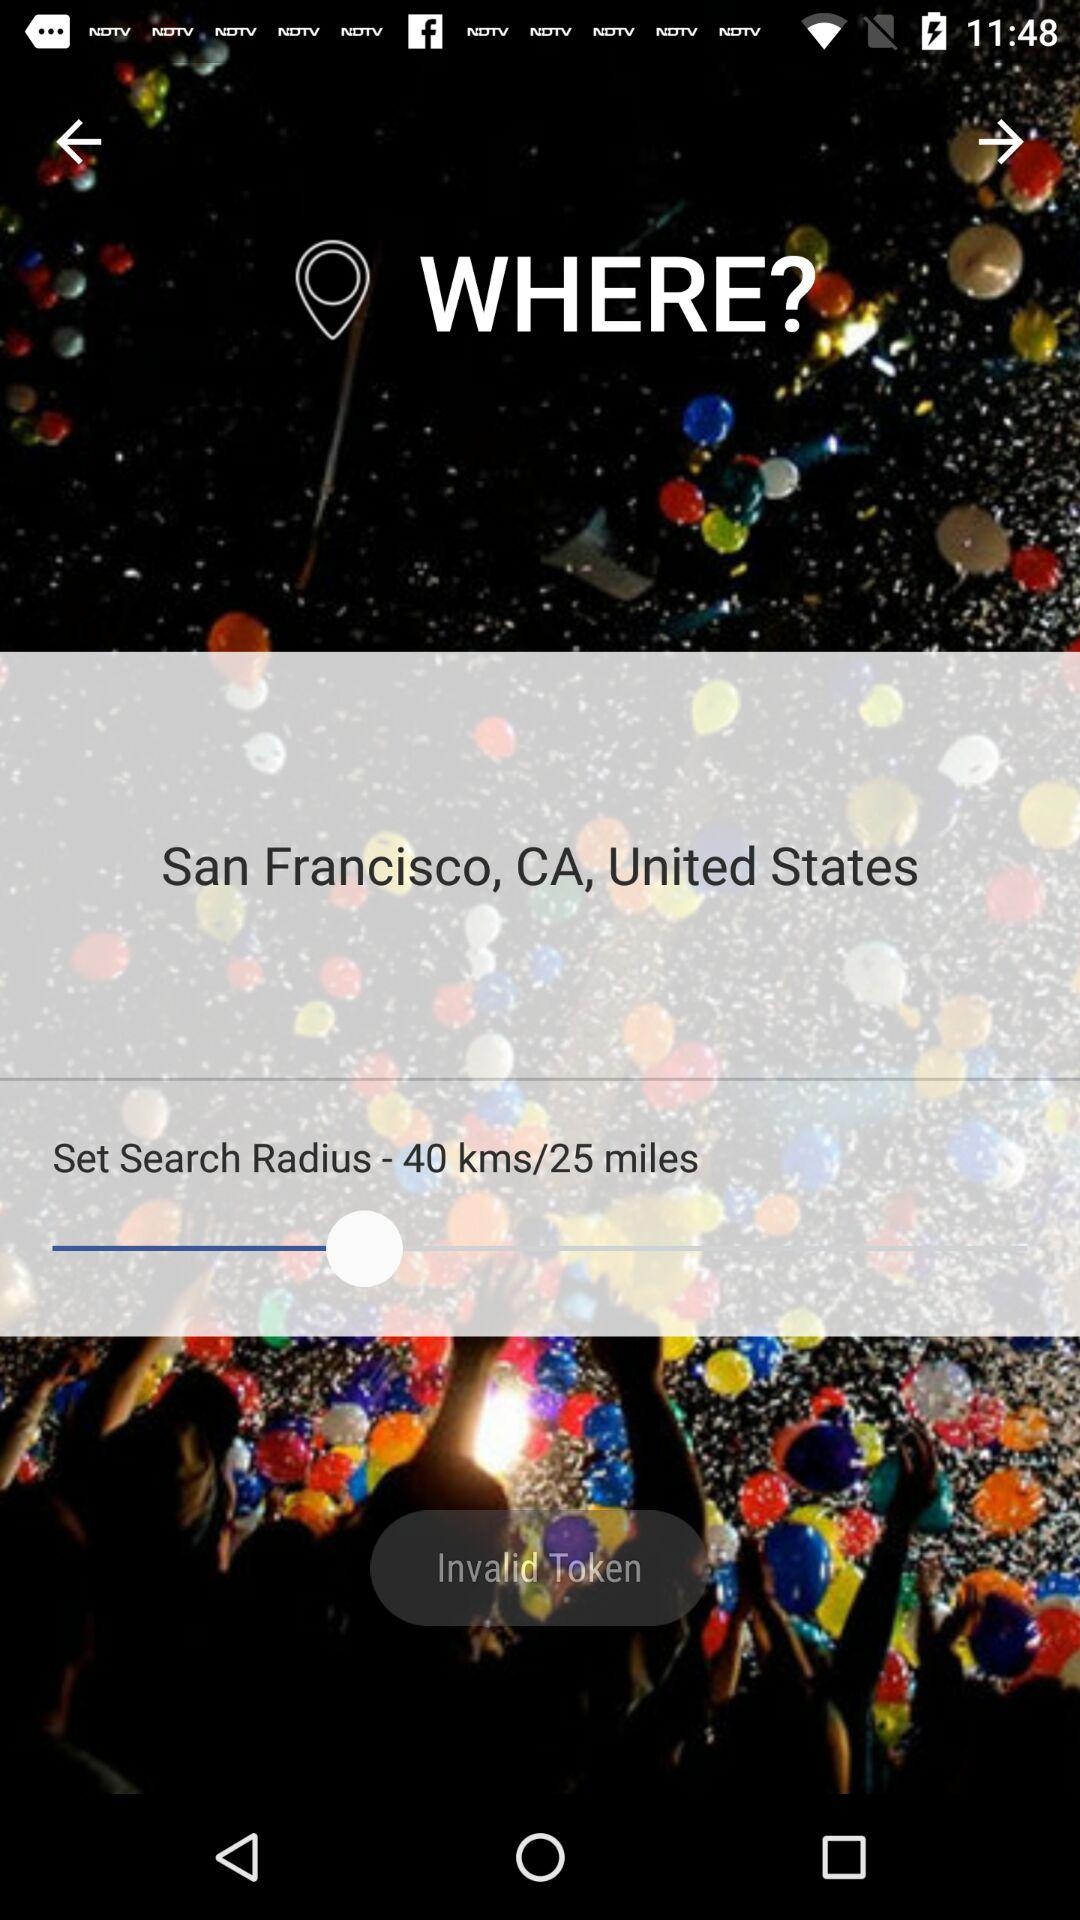What is the set radius? The set radius is 40 kms or 25 miles. 